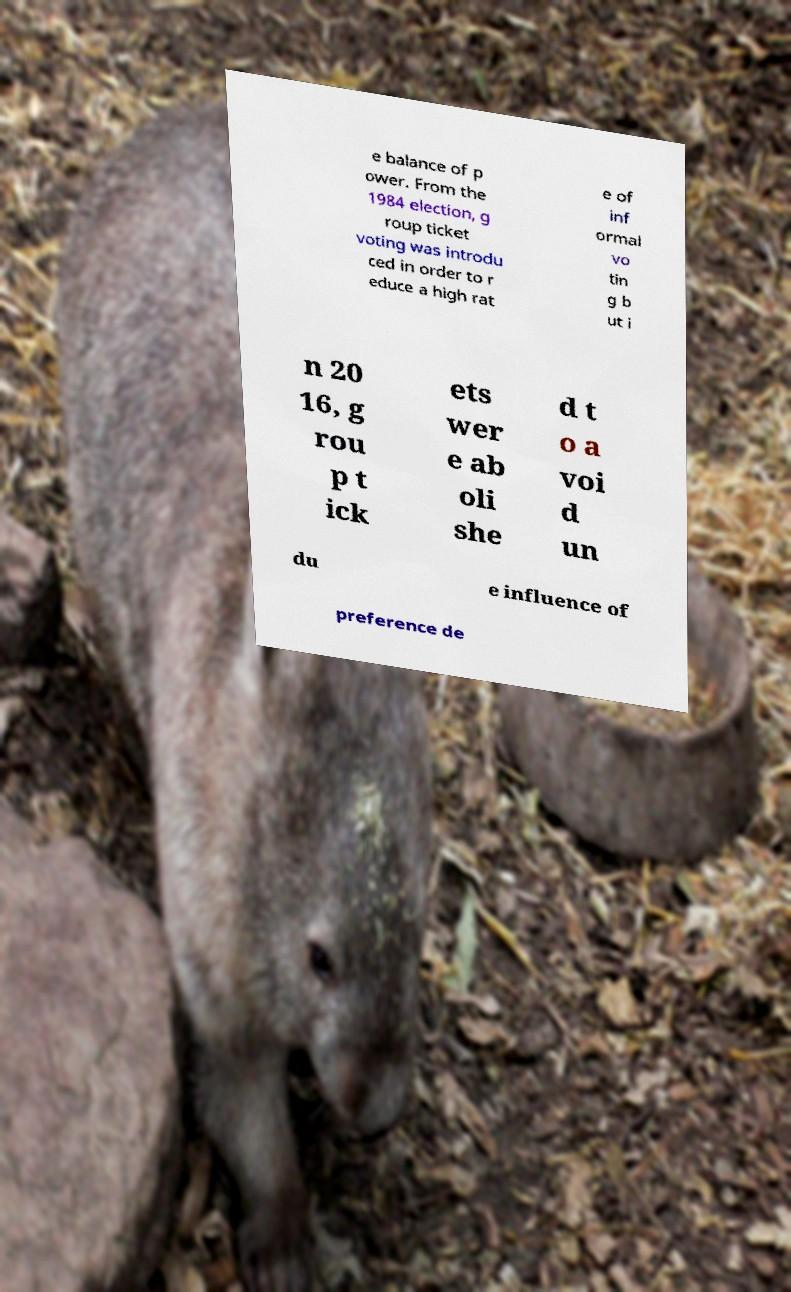Please read and relay the text visible in this image. What does it say? e balance of p ower. From the 1984 election, g roup ticket voting was introdu ced in order to r educe a high rat e of inf ormal vo tin g b ut i n 20 16, g rou p t ick ets wer e ab oli she d t o a voi d un du e influence of preference de 